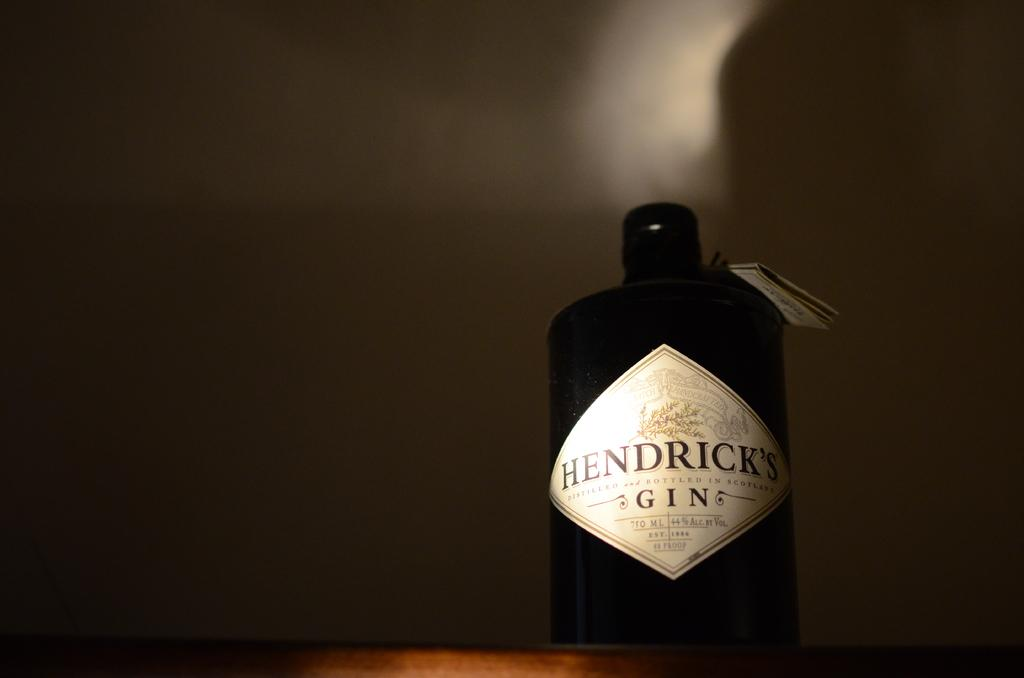<image>
Share a concise interpretation of the image provided. Small black bottle with a label that says "Hendricks Gin" on it. 